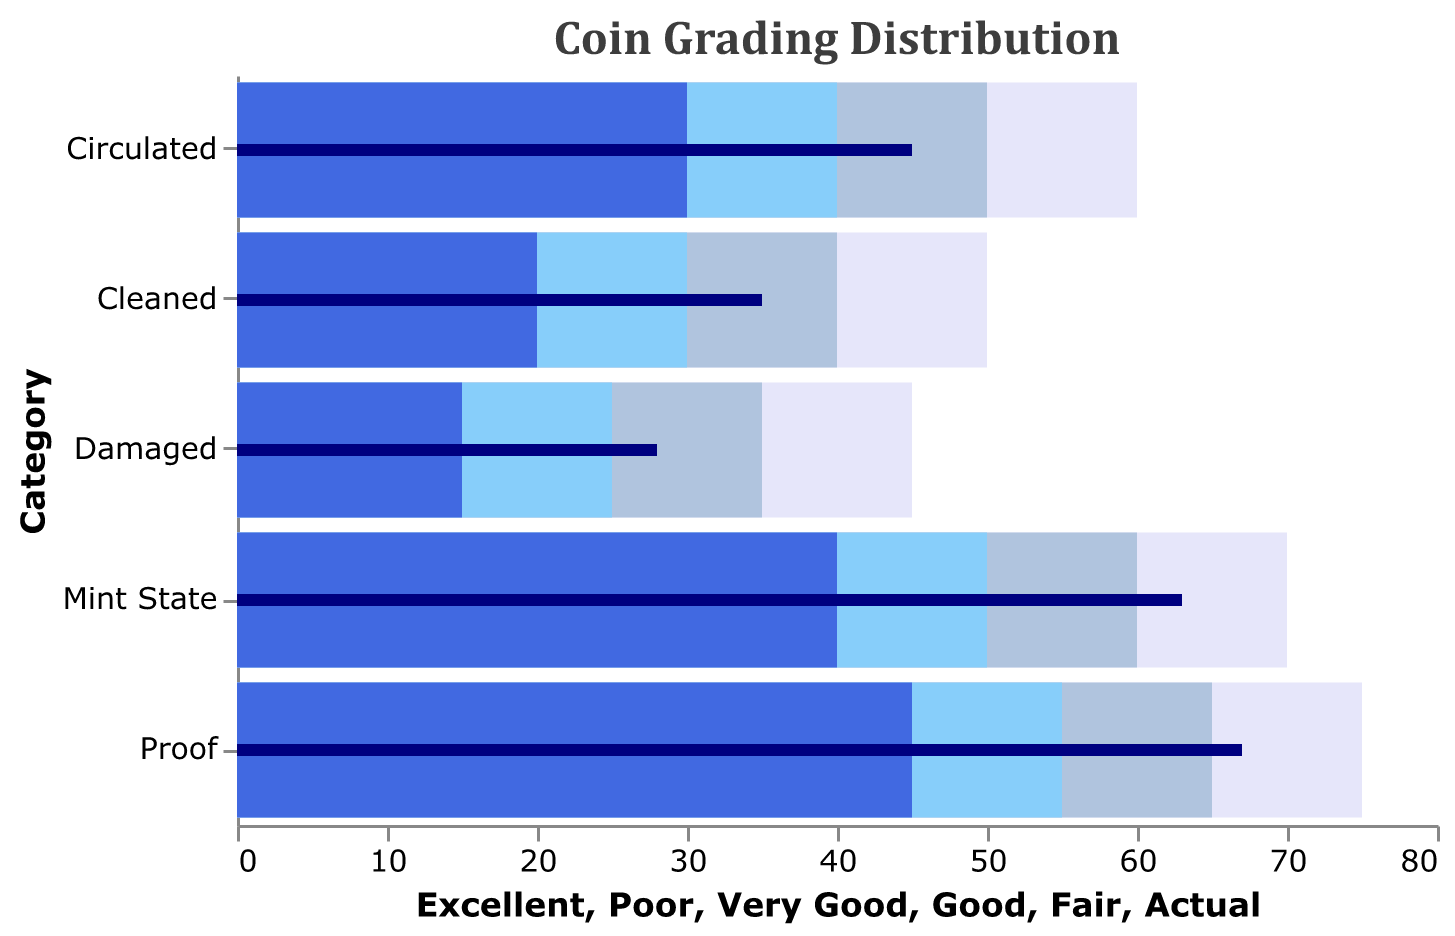What is the color of the bars representing the 'Excellent' range? The 'Excellent' range bars are the most extended bars and are colored lightly. By observing the legend and bars, you can identify that the 'Excellent' range is represented by the bars with the lightest color, which appears in a lavender shade.
Answer: Lavender What is the actual grading score for the 'Proof' category? The actual grading score for each category is shown as a thin dark bar at a specific point across the background of colored bars. For the 'Proof' category, this thin dark bar intersects at 67.
Answer: 67 Which category has the lowest actual grading score? To find the lowest actual grading score, look at the dark bars representing the actual scores. The lowest bar appears next to the 'Damaged' category, intersecting at 28.
Answer: Damaged How does the actual grading score for 'Mint State' compare to 'Circulated'? The 'Mint State' actual score is shown at 63, whereas 'Circulated' is marked at 45. The 'Mint State' score is higher than the 'Circulated' score.
Answer: Mint State is higher than Circulated What is the sum of the 'Good' range value for all given categories? To find this sum, add up the 'Good' range values for each category: Mint State (50) + Circulated (40) + Proof (55) + Cleaned (30) + Damaged (25) = 200.
Answer: 200 In which range does the 'Cleaned' category's actual score fall? The 'Cleaned' actual score (35) is represented by a dark bar. This bar falls between the 'Fair' (20-30) and 'Good' (30-40) ranges, indicating it is within the 'Good' range.
Answer: Good Between 'Mint State' and 'Proof', which category has a broader 'Excellent' range? Observe the extent of the 'Excellent' range bars for both categories. 'Mint State' has an 'Excellent' range from 60 to 70, a span of 10 units. 'Proof' has an 'Excellent' range from 65 to 75, also spanning 10 units. Both categories have the same breadth.
Answer: Same breadth How do the 'Very Good' ranges of 'Circulated' and 'Damaged' compare? The 'Very Good' range for 'Circulated' is from 50 to 60, and for 'Damaged' from 35 to 45. The 'Circulated' range is higher than the 'Damaged' range.
Answer: Circulated is higher than Damaged What is the average number of the 'Fair' values across all categories? Calculate the average by summing the 'Fair' values: Mint State (40) + Circulated (30) + Proof (45) + Cleaned (20) + Damaged (15) = 150. Then, divide by the number of categories, 150/5 = 30.
Answer: 30 